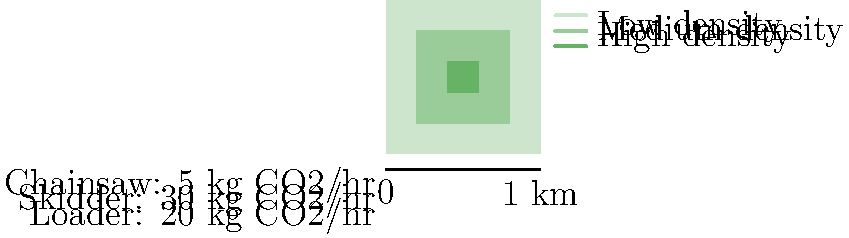Using the forest density map and equipment specifications provided, estimate the total carbon footprint of a logging operation that clears the entire 1 km² area in 8 hours. Assume that the operation uses 1 chainsaw, 1 skidder, and 1 loader continuously throughout the 8-hour period, and that the carbon emissions are directly proportional to the forest density (with high density areas taking twice as long to clear as low density areas). To estimate the total carbon footprint, we need to follow these steps:

1. Calculate the area of each density zone:
   - Low density: $1 \text{ km}^2 - 0.36 \text{ km}^2 = 0.64 \text{ km}^2$
   - Medium density: $0.36 \text{ km}^2 - 0.04 \text{ km}^2 = 0.32 \text{ km}^2$
   - High density: $0.04 \text{ km}^2$

2. Assign relative clearing times based on density:
   - Low density: 1x
   - Medium density: 1.5x
   - High density: 2x

3. Calculate the weighted average clearing time:
   $\frac{(0.64 \times 1) + (0.32 \times 1.5) + (0.04 \times 2)}{1} = 1.2$

4. Adjust the 8-hour period by the weighted average:
   $8 \text{ hours} \times 1.2 = 9.6 \text{ hours}$

5. Calculate carbon emissions for each equipment:
   - Chainsaw: $5 \text{ kg CO}_2/\text{hr} \times 9.6 \text{ hr} = 48 \text{ kg CO}_2$
   - Skidder: $30 \text{ kg CO}_2/\text{hr} \times 9.6 \text{ hr} = 288 \text{ kg CO}_2$
   - Loader: $20 \text{ kg CO}_2/\text{hr} \times 9.6 \text{ hr} = 192 \text{ kg CO}_2$

6. Sum up the total carbon emissions:
   $48 + 288 + 192 = 528 \text{ kg CO}_2$
Answer: 528 kg CO₂ 